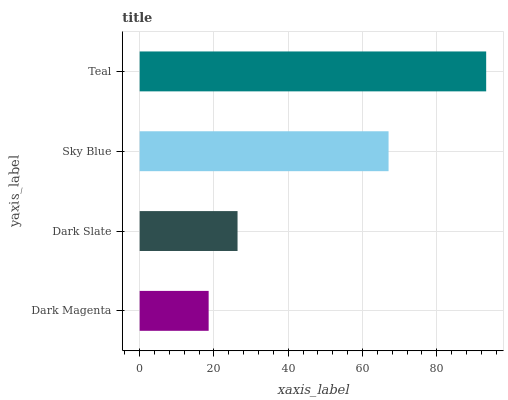Is Dark Magenta the minimum?
Answer yes or no. Yes. Is Teal the maximum?
Answer yes or no. Yes. Is Dark Slate the minimum?
Answer yes or no. No. Is Dark Slate the maximum?
Answer yes or no. No. Is Dark Slate greater than Dark Magenta?
Answer yes or no. Yes. Is Dark Magenta less than Dark Slate?
Answer yes or no. Yes. Is Dark Magenta greater than Dark Slate?
Answer yes or no. No. Is Dark Slate less than Dark Magenta?
Answer yes or no. No. Is Sky Blue the high median?
Answer yes or no. Yes. Is Dark Slate the low median?
Answer yes or no. Yes. Is Teal the high median?
Answer yes or no. No. Is Teal the low median?
Answer yes or no. No. 